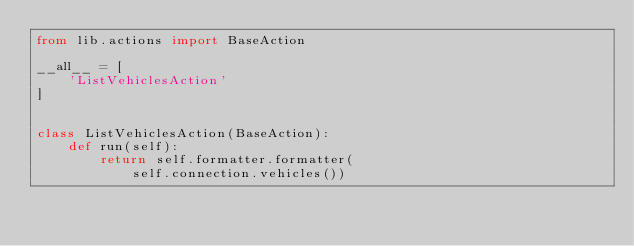<code> <loc_0><loc_0><loc_500><loc_500><_Python_>from lib.actions import BaseAction

__all__ = [
    'ListVehiclesAction'
]


class ListVehiclesAction(BaseAction):
    def run(self):
        return self.formatter.formatter(
            self.connection.vehicles())
</code> 